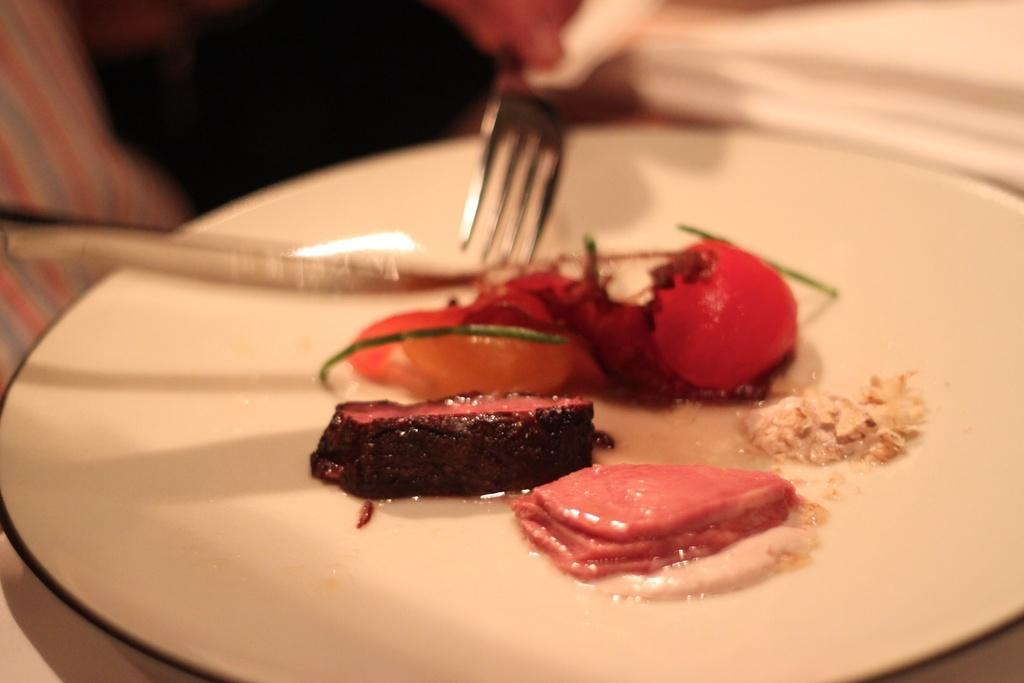What is on the white plate in the image? There are eatables on a white plate. What utensils are present beside the plate? There is a knife and a fork beside the plate. How many bikes are parked next to the table in the image? There are no bikes present in the image. Who is the manager of the restaurant in the image? There is no indication of a restaurant or a manager in the image. 